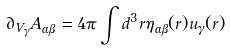<formula> <loc_0><loc_0><loc_500><loc_500>\partial _ { V _ { \gamma } } A _ { \alpha \beta } = 4 \pi \int d ^ { 3 } { r } \eta _ { \alpha \beta } ( { r } ) u _ { \gamma } ( { r } )</formula> 